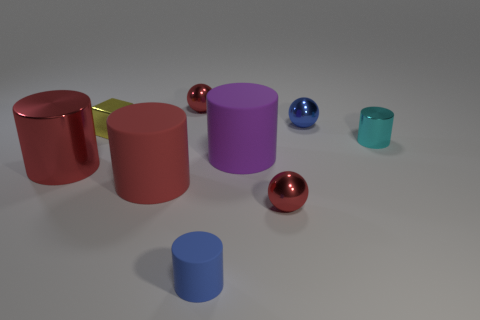What shapes are visible in the image? The image features a variety of shapes including cylinders, spheres, and a cube. The composition showcases both the geometry and the interplay of light and shadow on these objects. 